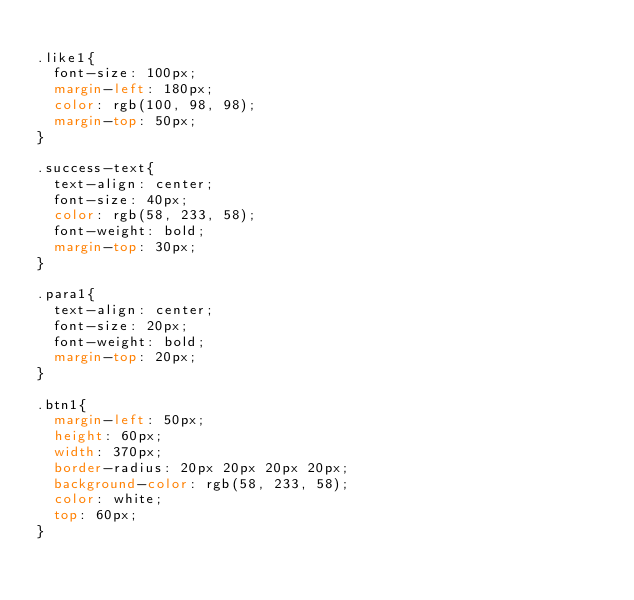Convert code to text. <code><loc_0><loc_0><loc_500><loc_500><_CSS_>
.like1{
  font-size: 100px;
  margin-left: 180px;
  color: rgb(100, 98, 98);
  margin-top: 50px;
}

.success-text{
  text-align: center;
  font-size: 40px;
  color: rgb(58, 233, 58);
  font-weight: bold;
  margin-top: 30px;
}

.para1{
  text-align: center;
  font-size: 20px;
  font-weight: bold;
  margin-top: 20px;
}

.btn1{
  margin-left: 50px;
  height: 60px;
  width: 370px;
  border-radius: 20px 20px 20px 20px;
  background-color: rgb(58, 233, 58);
  color: white;
  top: 60px;
}









</code> 